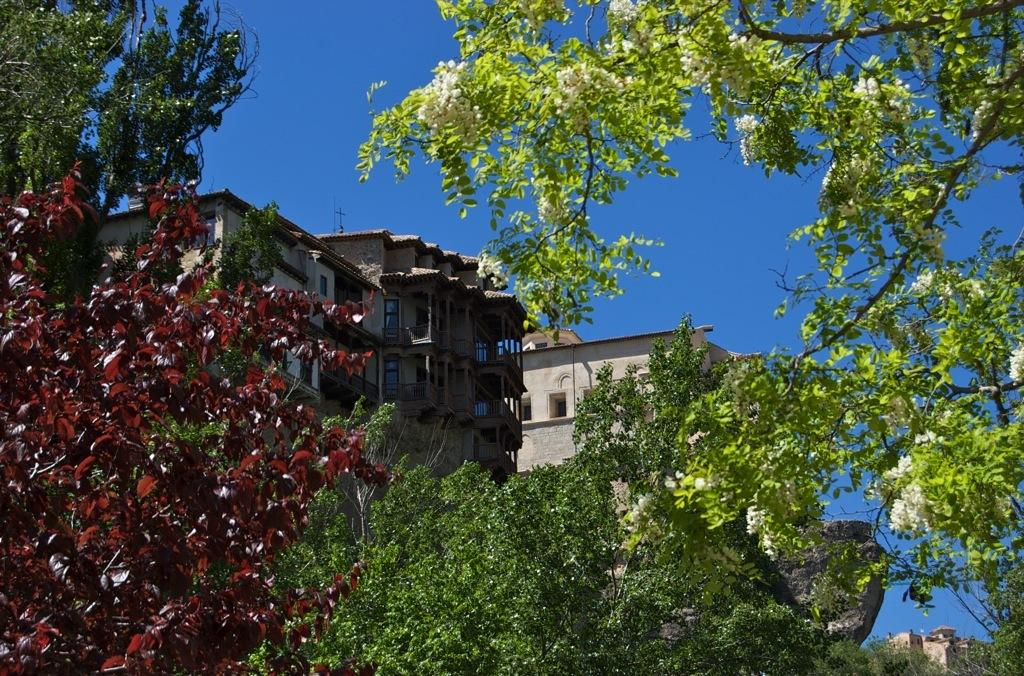What type of structures can be seen in the image? There are buildings in the image. What other natural elements are present in the image? There are trees in the image. What color is the sky in the image? The sky is blue in the image. How many ears can be seen on the trees in the image? There are no ears present on the trees in the image, as trees do not have ears. 